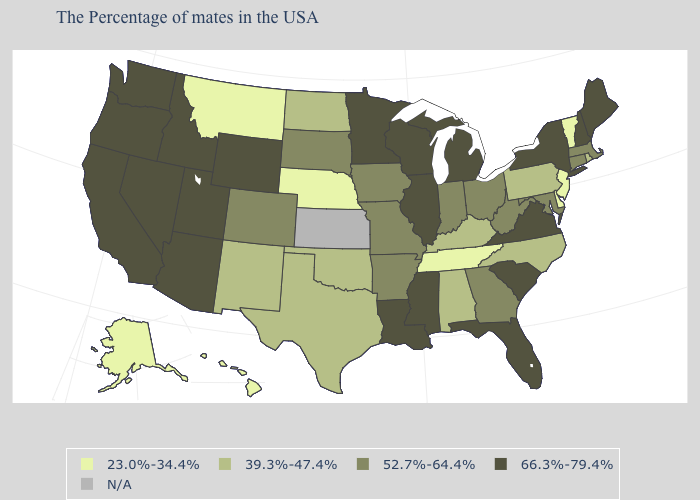What is the lowest value in states that border South Carolina?
Short answer required. 39.3%-47.4%. Name the states that have a value in the range 23.0%-34.4%?
Write a very short answer. Vermont, New Jersey, Delaware, Tennessee, Nebraska, Montana, Alaska, Hawaii. Is the legend a continuous bar?
Keep it brief. No. What is the lowest value in the USA?
Short answer required. 23.0%-34.4%. What is the lowest value in states that border Massachusetts?
Give a very brief answer. 23.0%-34.4%. Does Nebraska have the lowest value in the USA?
Give a very brief answer. Yes. What is the value of Delaware?
Write a very short answer. 23.0%-34.4%. Does the map have missing data?
Give a very brief answer. Yes. Name the states that have a value in the range 23.0%-34.4%?
Answer briefly. Vermont, New Jersey, Delaware, Tennessee, Nebraska, Montana, Alaska, Hawaii. What is the value of Mississippi?
Answer briefly. 66.3%-79.4%. Which states have the lowest value in the USA?
Keep it brief. Vermont, New Jersey, Delaware, Tennessee, Nebraska, Montana, Alaska, Hawaii. What is the lowest value in the USA?
Concise answer only. 23.0%-34.4%. Does the first symbol in the legend represent the smallest category?
Give a very brief answer. Yes. Among the states that border Iowa , does Minnesota have the lowest value?
Answer briefly. No. 